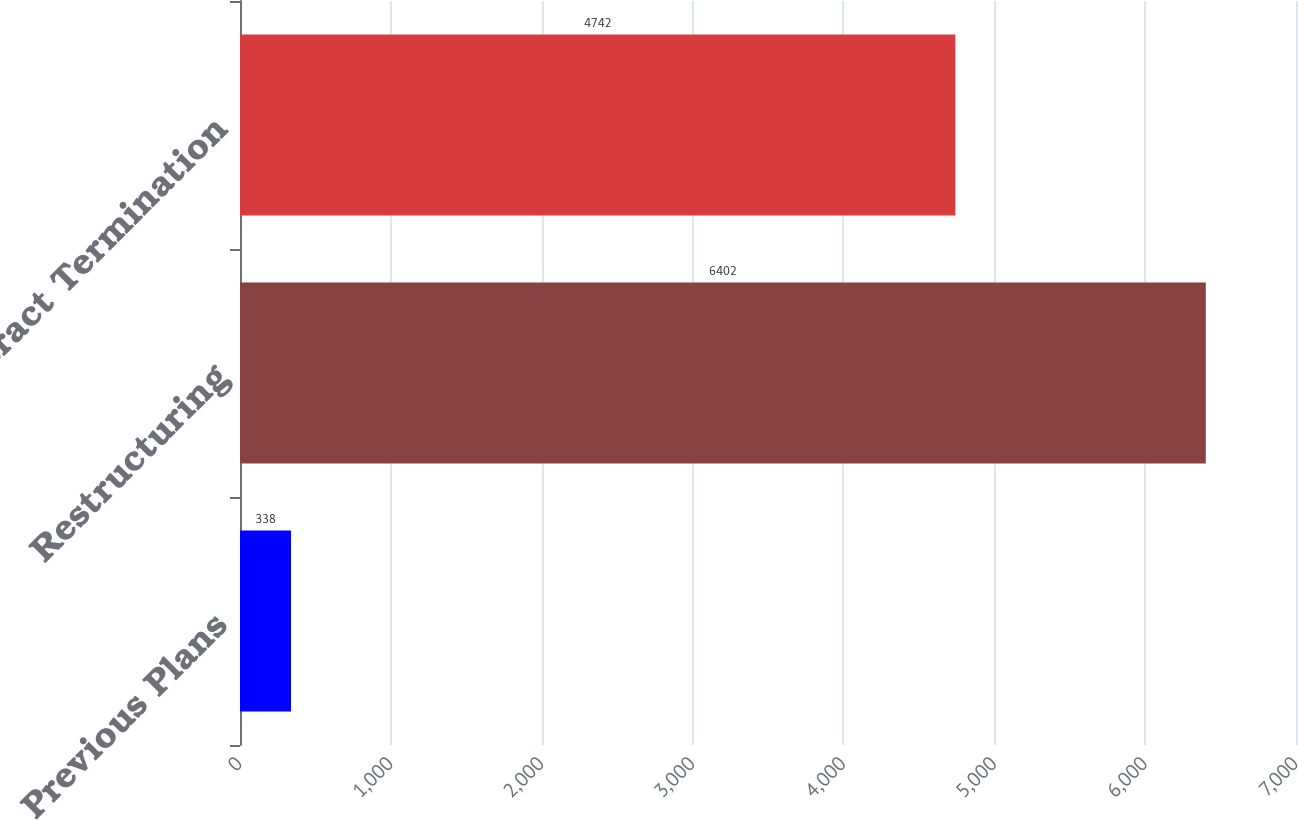Convert chart to OTSL. <chart><loc_0><loc_0><loc_500><loc_500><bar_chart><fcel>Previous Plans<fcel>Restructuring<fcel>Contract Termination<nl><fcel>338<fcel>6402<fcel>4742<nl></chart> 